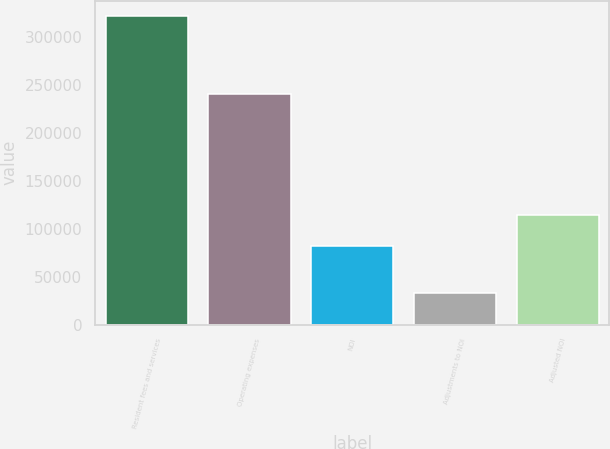Convert chart to OTSL. <chart><loc_0><loc_0><loc_500><loc_500><bar_chart><fcel>Resident fees and services<fcel>Operating expenses<fcel>NOI<fcel>Adjustments to NOI<fcel>Adjusted NOI<nl><fcel>321209<fcel>239702<fcel>81507<fcel>32863<fcel>114370<nl></chart> 